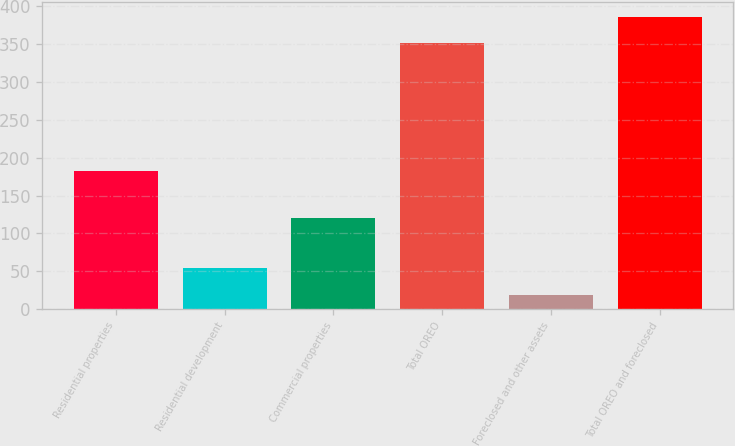Convert chart. <chart><loc_0><loc_0><loc_500><loc_500><bar_chart><fcel>Residential properties<fcel>Residential development<fcel>Commercial properties<fcel>Total OREO<fcel>Foreclosed and other assets<fcel>Total OREO and foreclosed<nl><fcel>183<fcel>54.1<fcel>120<fcel>351<fcel>19<fcel>386.1<nl></chart> 